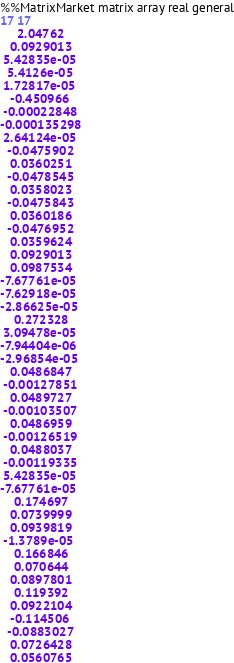Convert code to text. <code><loc_0><loc_0><loc_500><loc_500><_ObjectiveC_>%%MatrixMarket matrix array real general
17 17
     2.04762
   0.0929013
 5.42835e-05
  5.4126e-05
 1.72817e-05
   -0.450966
 -0.00022848
-0.000135298
 2.64124e-05
  -0.0475902
   0.0360251
  -0.0478545
   0.0358023
  -0.0475843
   0.0360186
  -0.0476952
   0.0359624
   0.0929013
   0.0987534
-7.67761e-05
-7.62918e-05
-2.86625e-05
    0.272328
 3.09478e-05
-7.94404e-06
-2.96854e-05
   0.0486847
 -0.00127851
   0.0489727
 -0.00103507
   0.0486959
 -0.00126519
   0.0488037
 -0.00119335
 5.42835e-05
-7.67761e-05
    0.174697
   0.0739999
   0.0939819
 -1.3789e-05
    0.166846
    0.070644
   0.0897801
    0.119392
   0.0922104
   -0.114506
  -0.0883027
   0.0726428
   0.0560765</code> 